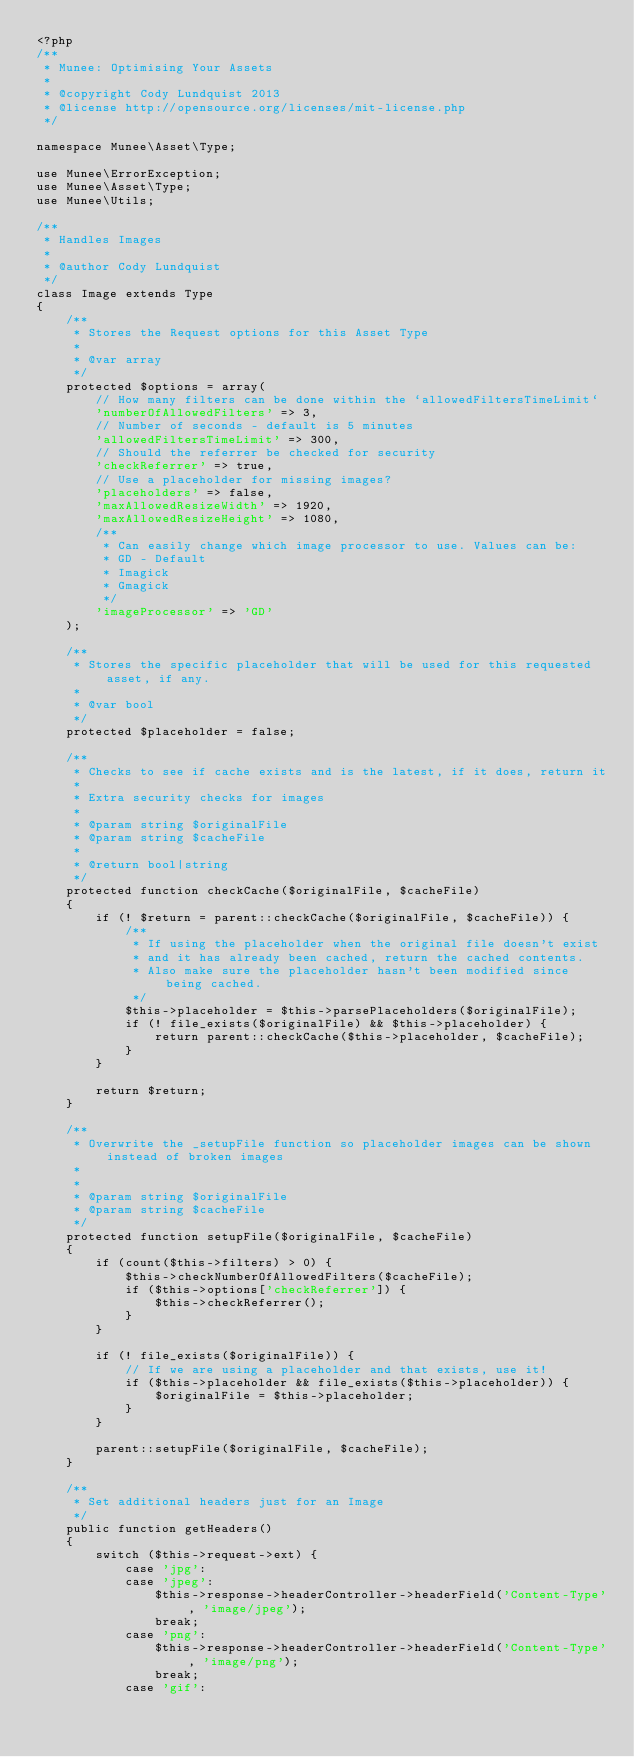Convert code to text. <code><loc_0><loc_0><loc_500><loc_500><_PHP_><?php
/**
 * Munee: Optimising Your Assets
 *
 * @copyright Cody Lundquist 2013
 * @license http://opensource.org/licenses/mit-license.php
 */

namespace Munee\Asset\Type;

use Munee\ErrorException;
use Munee\Asset\Type;
use Munee\Utils;

/**
 * Handles Images
 *
 * @author Cody Lundquist
 */
class Image extends Type
{
    /**
     * Stores the Request options for this Asset Type
     *
     * @var array
     */
    protected $options = array(
        // How many filters can be done within the `allowedFiltersTimeLimit`
        'numberOfAllowedFilters' => 3,
        // Number of seconds - default is 5 minutes
        'allowedFiltersTimeLimit' => 300,
        // Should the referrer be checked for security
        'checkReferrer' => true,
        // Use a placeholder for missing images?
        'placeholders' => false,
        'maxAllowedResizeWidth' => 1920,
        'maxAllowedResizeHeight' => 1080,
        /**
         * Can easily change which image processor to use. Values can be:
         * GD - Default
         * Imagick
         * Gmagick
         */
        'imageProcessor' => 'GD'
    );

    /**
     * Stores the specific placeholder that will be used for this requested asset, if any.
     *
     * @var bool
     */
    protected $placeholder = false;

    /**
     * Checks to see if cache exists and is the latest, if it does, return it
     *
     * Extra security checks for images
     *
     * @param string $originalFile
     * @param string $cacheFile
     *
     * @return bool|string
     */
    protected function checkCache($originalFile, $cacheFile)
    {
        if (! $return = parent::checkCache($originalFile, $cacheFile)) {
            /**
             * If using the placeholder when the original file doesn't exist
             * and it has already been cached, return the cached contents.
             * Also make sure the placeholder hasn't been modified since being cached.
             */
            $this->placeholder = $this->parsePlaceholders($originalFile);
            if (! file_exists($originalFile) && $this->placeholder) {
                return parent::checkCache($this->placeholder, $cacheFile);
            }
        }

        return $return;
    }

    /**
     * Overwrite the _setupFile function so placeholder images can be shown instead of broken images
     *
     *
     * @param string $originalFile
     * @param string $cacheFile
     */
    protected function setupFile($originalFile, $cacheFile)
    {
        if (count($this->filters) > 0) {
            $this->checkNumberOfAllowedFilters($cacheFile);
            if ($this->options['checkReferrer']) {
                $this->checkReferrer();
            }
        }

        if (! file_exists($originalFile)) {
            // If we are using a placeholder and that exists, use it!
            if ($this->placeholder && file_exists($this->placeholder)) {
                $originalFile = $this->placeholder;
            }
        }

        parent::setupFile($originalFile, $cacheFile);
    }

    /**
     * Set additional headers just for an Image
     */
    public function getHeaders()
    {
        switch ($this->request->ext) {
            case 'jpg':
            case 'jpeg':
                $this->response->headerController->headerField('Content-Type', 'image/jpeg');
                break;
            case 'png':
                $this->response->headerController->headerField('Content-Type', 'image/png');
                break;
            case 'gif':</code> 